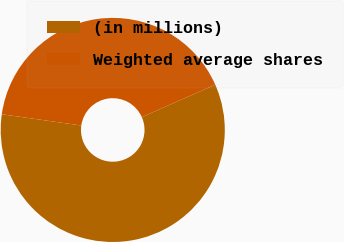Convert chart to OTSL. <chart><loc_0><loc_0><loc_500><loc_500><pie_chart><fcel>(in millions)<fcel>Weighted average shares<nl><fcel>58.86%<fcel>41.14%<nl></chart> 